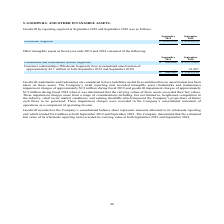According to Amcon Distributing's financial document, What does goodwill recorded on the Company’s consolidated balance sheet represent? represents amounts allocated to its wholesale reporting unit. The document states: "orded on the Company’s consolidated balance sheet represents amounts allocated to its wholesale reporting unit which totaled $4.4 million at both Sept..." Also, What are the respective intangible asset impairment charges during fiscal 2018 and 2019? The document shows two values: $1.9 million and $2.9 million. From the document: "nd tradenames) impairment charges of approximately $2.9 million during fiscal 2019 and goodwill impairment charges of approximately $1.9 million durin..." Also, What are the respective trademarks and tradenames at the end of fiscal year 2018 and 2019? The document shows two values: $3,373,269 and $500,000. From the document: "marks and tradenames (Retail Segment) $ 500,000 $ 3,373,269 Trademarks and tradenames (Retail Segment) $ 500,000 $ 3,373,269..." Also, can you calculate: What is the percentage change in the value of the company's trademarks and tradenames between 2018 and 2019? To answer this question, I need to perform calculations using the financial data. The calculation is: (500,000 - 3,373,269)/3,373,269 , which equals -85.18 (percentage). This is based on the information: "marks and tradenames (Retail Segment) $ 500,000 $ 3,373,269 Trademarks and tradenames (Retail Segment) $ 500,000 $ 3,373,269..." The key data points involved are: 3,373,269, 500,000. Also, can you calculate: What is the percentage change in the value of company's customer relationships between 2018 and 2019? To answer this question, I need to perform calculations using the financial data. The calculation is: (0 - 41,667)/41,667 , which equals -100 (percentage). This is based on the information: "lion at both September 2019 and September 2018) — 41,667 of approximately $2.1 million at both September 2019 and September 2018) — 41,667..." The key data points involved are: 41,667. Also, can you calculate: What is the value of the company's trademarks and tradenames as a percentage of its total intangible assets in 2018? Based on the calculation: 3,373,269/3,414,936 , the result is 98.78 (percentage). This is based on the information: "marks and tradenames (Retail Segment) $ 500,000 $ 3,373,269 $ 500,000 $ 3,414,936..." The key data points involved are: 3,373,269, 3,414,936. 